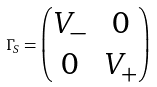<formula> <loc_0><loc_0><loc_500><loc_500>\Gamma _ { S } = \begin{pmatrix} V _ { - } & 0 \\ 0 & V _ { + } \end{pmatrix}</formula> 